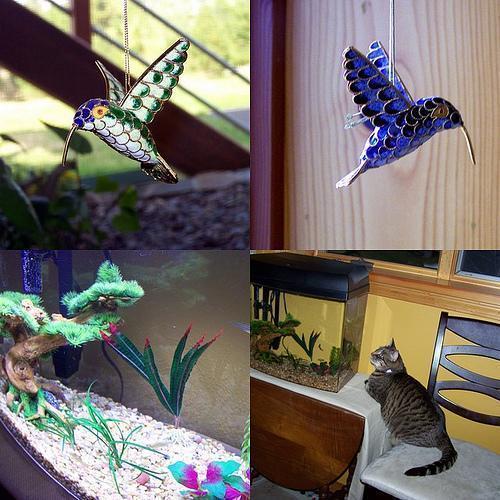What type of birds are in the top images?
Indicate the correct response by choosing from the four available options to answer the question.
Options: Crows, doves, starlings, hummingbirds. Hummingbirds. 